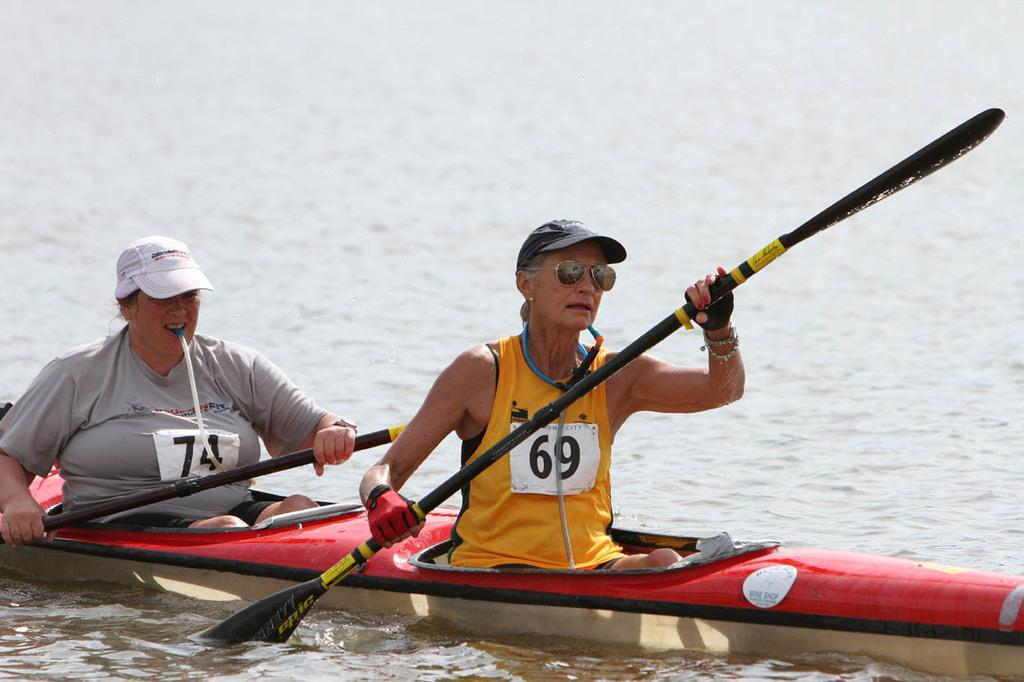How many people are in the image? There are two persons in the image. What are the persons holding in the image? The persons are holding paddles. What type of boat are the persons sitting in? The persons are sitting in a kayak boat. Where is the kayak boat located in the image? The kayak boat is on the water. What type of soup is being served in the kayak boat? There is no soup present in the image; the persons are holding paddles and sitting in a kayak boat on the water. 